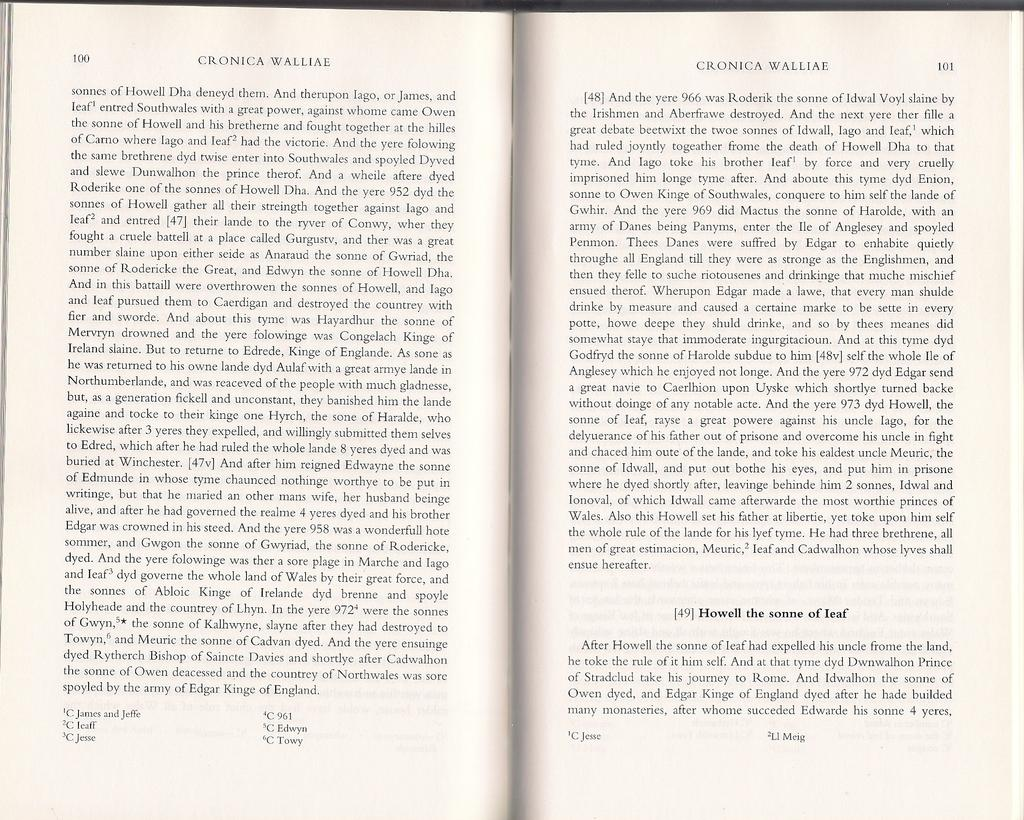Provide a one-sentence caption for the provided image. A book open to pages 100 and 101 with the title Cronica Wolliae on top. 